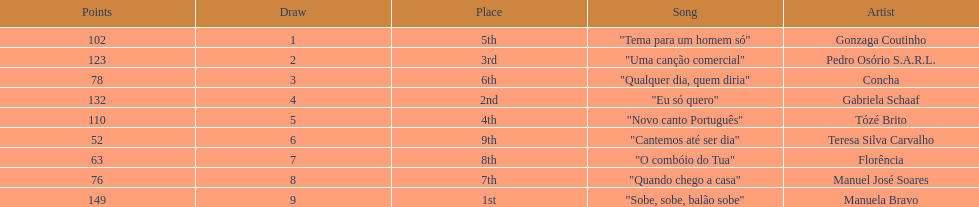Who scored the most points? Manuela Bravo. 